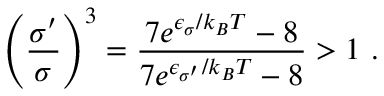Convert formula to latex. <formula><loc_0><loc_0><loc_500><loc_500>\left ( \frac { \sigma ^ { \prime } } { \sigma } \right ) ^ { 3 } = \frac { 7 e ^ { \epsilon _ { \sigma } / k _ { B } T } - 8 } { 7 e ^ { \epsilon _ { \sigma ^ { \prime } } / k _ { B } T } - 8 } > 1 .</formula> 